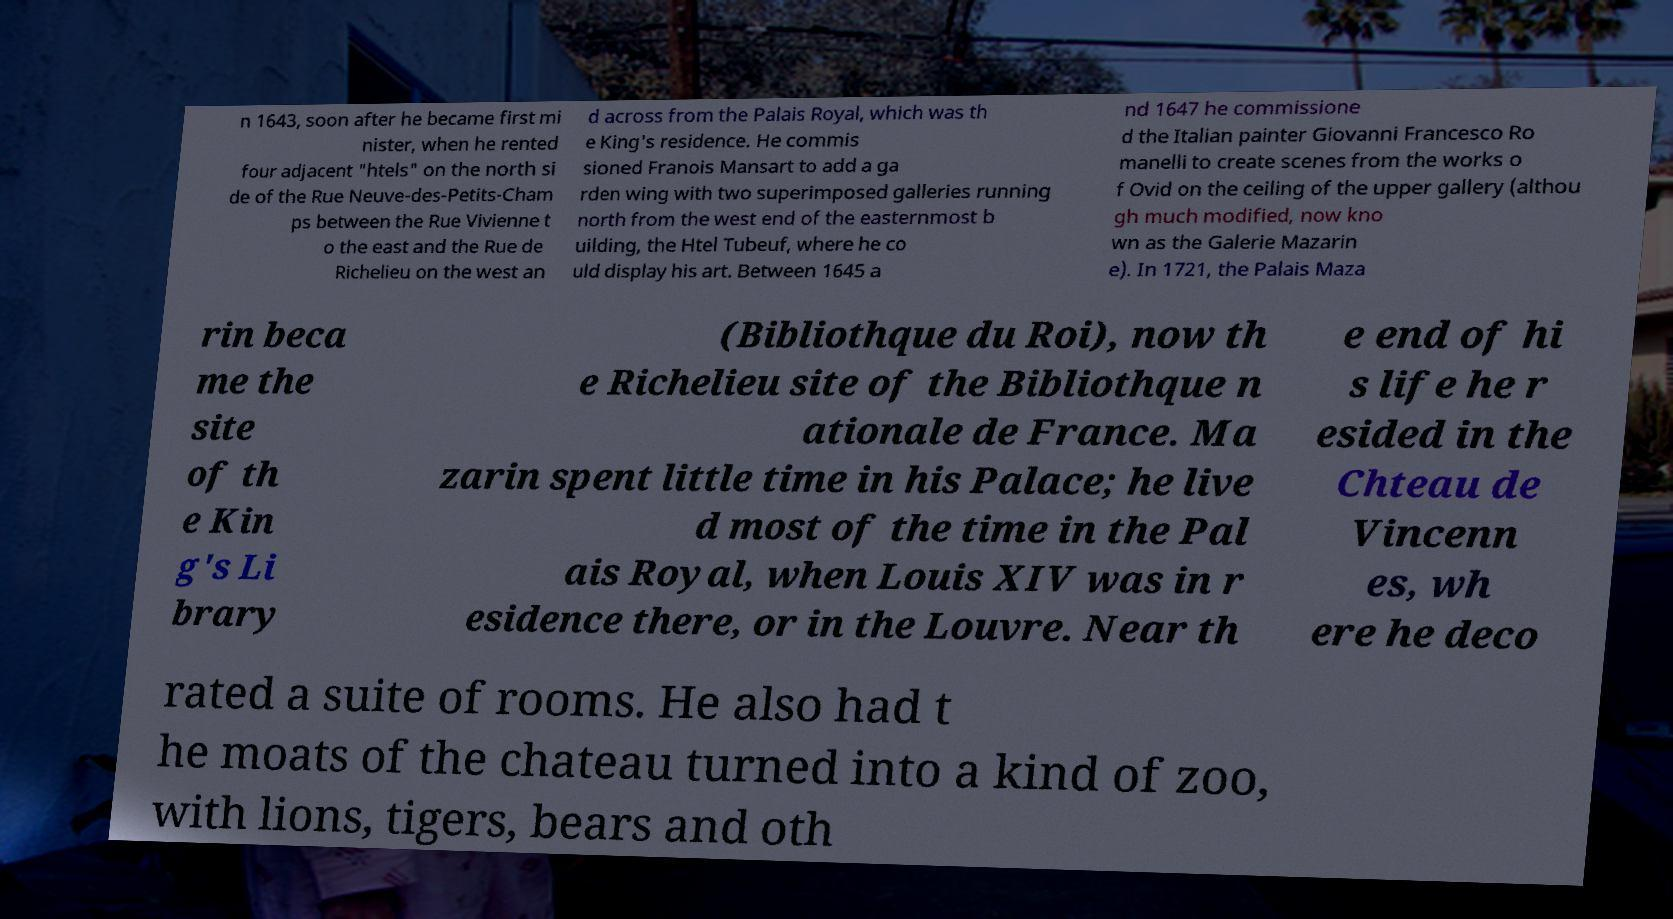Can you accurately transcribe the text from the provided image for me? n 1643, soon after he became first mi nister, when he rented four adjacent "htels" on the north si de of the Rue Neuve-des-Petits-Cham ps between the Rue Vivienne t o the east and the Rue de Richelieu on the west an d across from the Palais Royal, which was th e King's residence. He commis sioned Franois Mansart to add a ga rden wing with two superimposed galleries running north from the west end of the easternmost b uilding, the Htel Tubeuf, where he co uld display his art. Between 1645 a nd 1647 he commissione d the Italian painter Giovanni Francesco Ro manelli to create scenes from the works o f Ovid on the ceiling of the upper gallery (althou gh much modified, now kno wn as the Galerie Mazarin e). In 1721, the Palais Maza rin beca me the site of th e Kin g's Li brary (Bibliothque du Roi), now th e Richelieu site of the Bibliothque n ationale de France. Ma zarin spent little time in his Palace; he live d most of the time in the Pal ais Royal, when Louis XIV was in r esidence there, or in the Louvre. Near th e end of hi s life he r esided in the Chteau de Vincenn es, wh ere he deco rated a suite of rooms. He also had t he moats of the chateau turned into a kind of zoo, with lions, tigers, bears and oth 